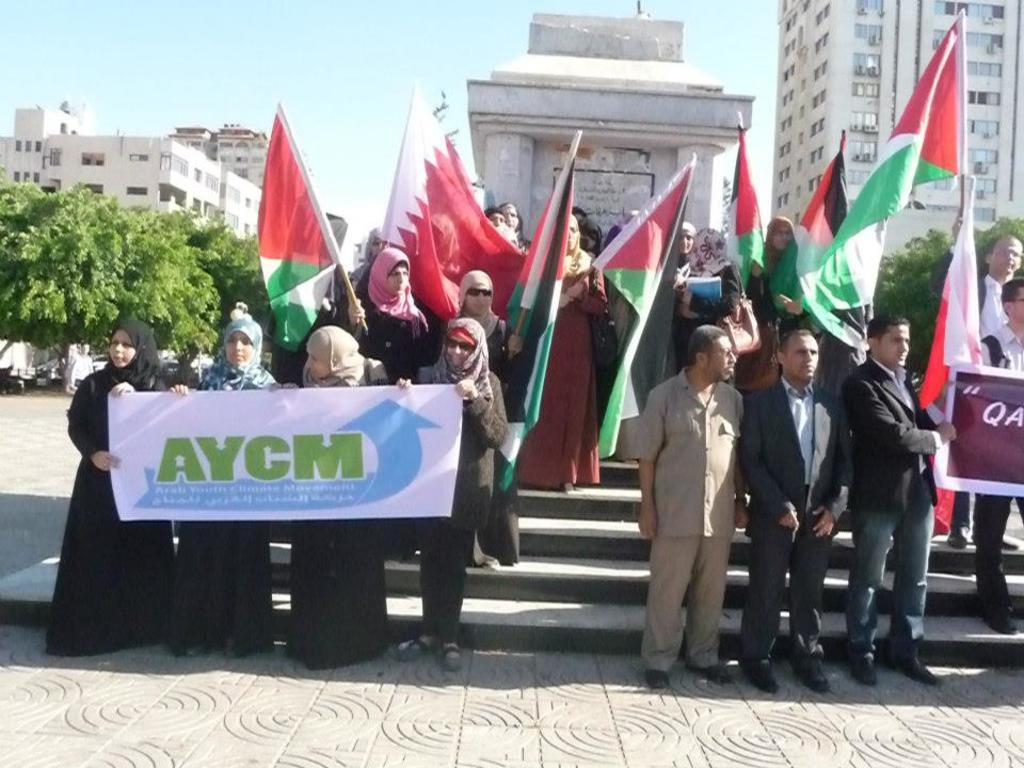What is happening with the group of people in the image? The people are protesting in the image. What items can be seen being used by the protesters? Flags and banners are present in the image. What can be seen in the background of the image? There are buildings and trees in the background of the image. What type of popcorn is being served at the protest in the image? There is no popcorn present in the image; it is a protest with people holding flags and banners. 